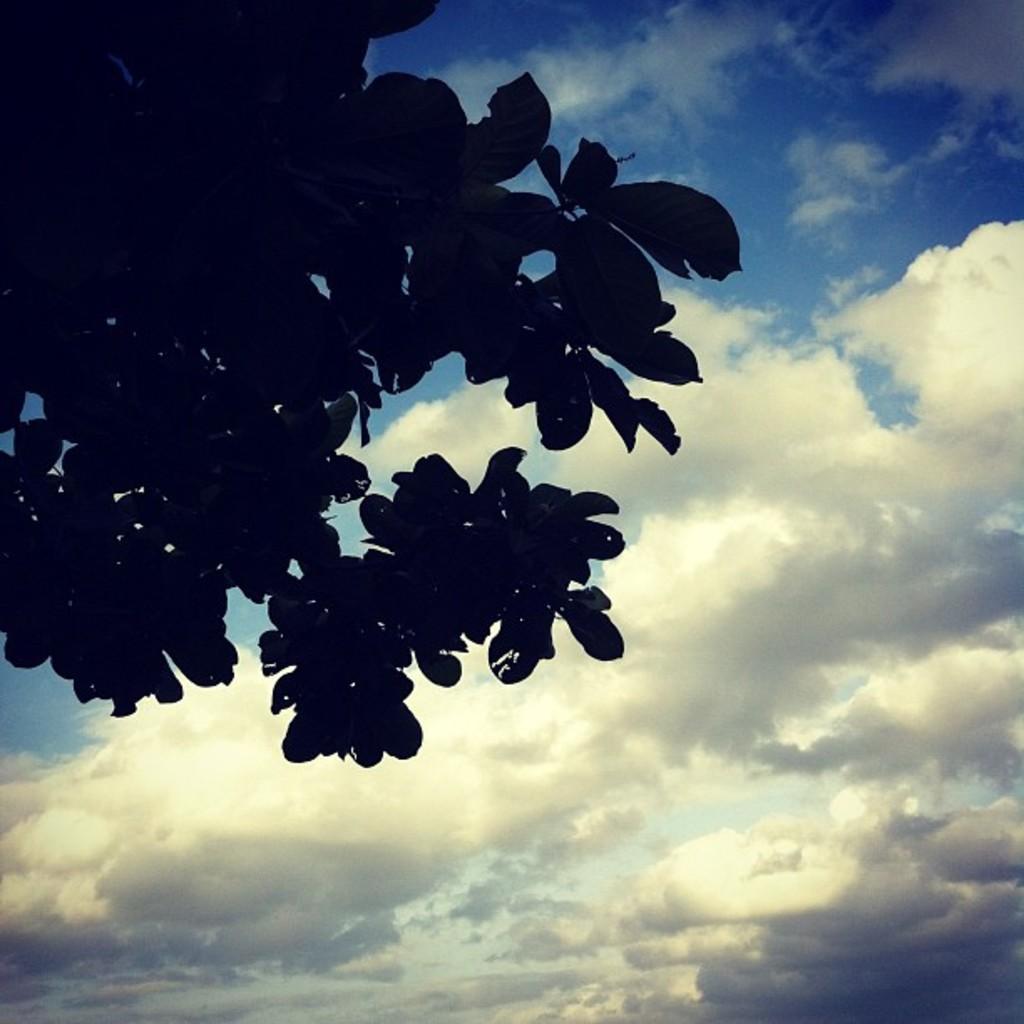How would you summarize this image in a sentence or two? In this image we can see, in the foreground there are many leaves of a tree and the background is the sky. 